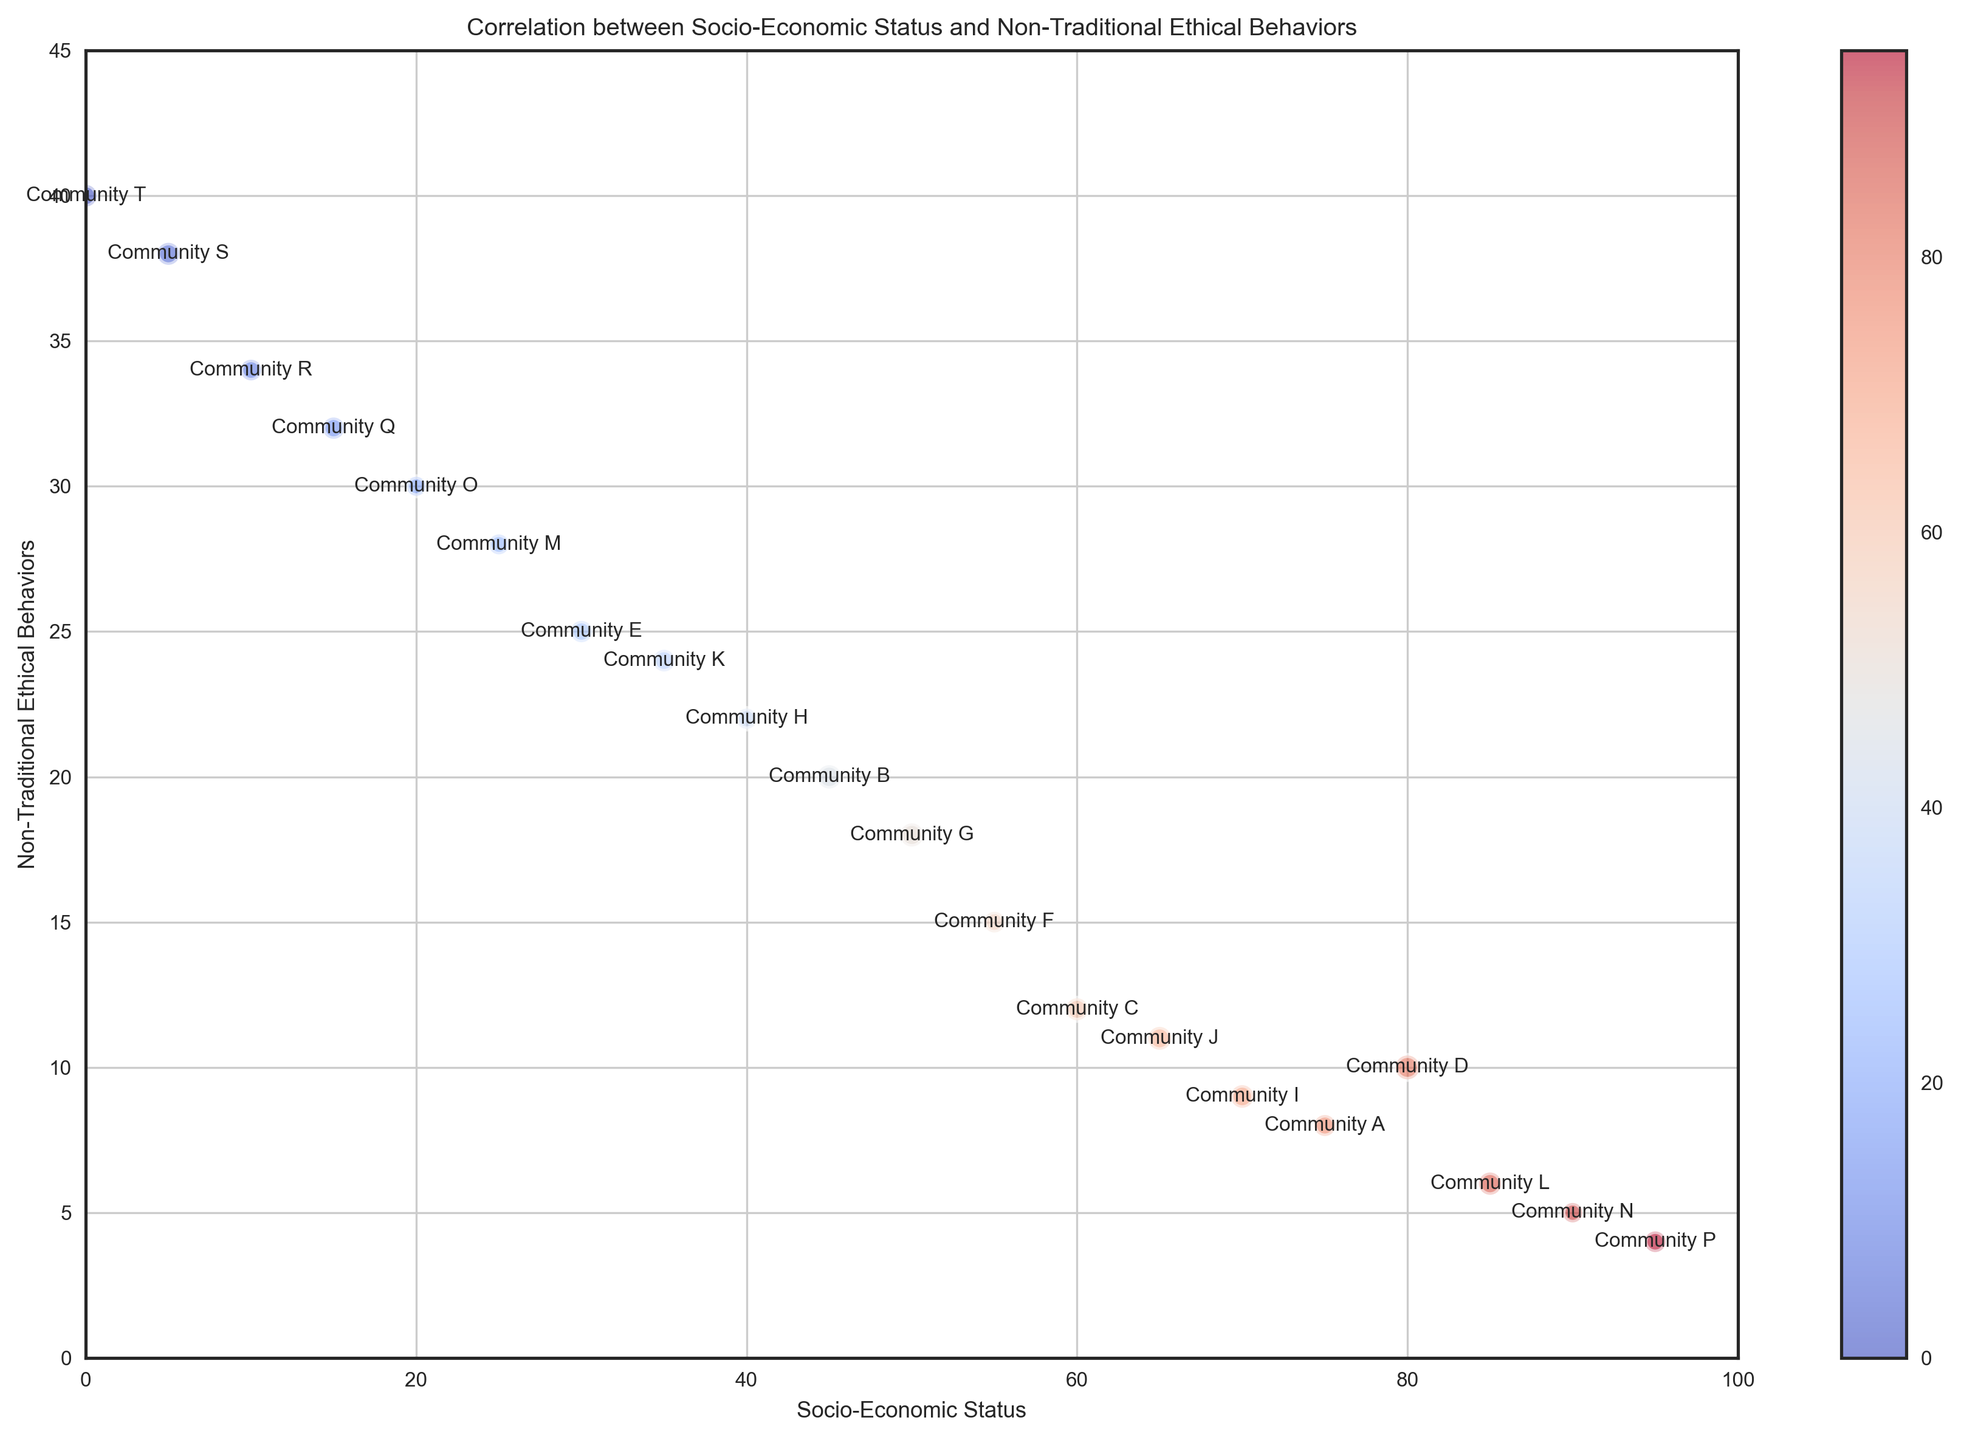How many communities have a socio-economic status higher than 70? From the figure, identify the communities with a socio-economic status higher than 70. These are Communities D, I, J, L, N, and P.
Answer: 6 Which community has the highest practice of non-traditional ethical behaviors? From the figure, look for the community with the highest value on the y-axis for non-traditional ethical behaviors. This is Community T with the highest value at 40.
Answer: Community T Compare the socio-economic status and non-traditional ethical behaviors of Community A and Community S. Which community has higher values in each category? Visually inspect the socio-economic status and non-traditional ethical behaviors of Community A and Community S. Community A has a higher socio-economic status (75) compared to Community S (5). Conversely, Community S has a higher practice of non-traditional ethical behaviors (38) compared to Community A (8).
Answer: Community A has higher socio-economic status; Community S has higher non-traditional ethical behaviors What is the average socio-economic status of communities with a non-traditional ethical behavior value between 10 and 20, inclusive? Identify communities with non-traditional ethical behavior values between 10 and 20 (Communities C, D, F, G, I, J). Sum their socio-economic status (60 + 80 + 55 + 50 + 70 + 65 = 380) and divide by the number of communities (6).
Answer: 63.33 Which communities are the outliers in terms of non-traditional ethical behaviors? Outliers have exceptionally high or low values. From the figure, Communities T, S, R, Q, and O have very high non-traditional ethical behaviors, and Communities N and P have very low values.
Answer: T, S, R, Q, O (high); N, P (low) How does population size influence the bubble size in the plot? Provide an example. Larger populations correspond to larger bubble sizes. For example, Community D with a population of 25,000 has a larger bubble compared to Community T with a population of 17,000.
Answer: Larger population, larger bubble Do any communities have both a high socio-economic status and high practice of non-traditional ethical behaviors? From the figure, look for communities in the upper right quadrant. None of the communities have both high socio-economic status (>70) and high non-traditional ethical behaviors (>30).
Answer: No What color are the bubbles for communities with the lowest socio-economic statuses? Examine the color gradient used for socio-economic status in the figure. Communities with the lowest socio-economic statuses (T, S, R) are colored in shades of blue.
Answer: Blue 